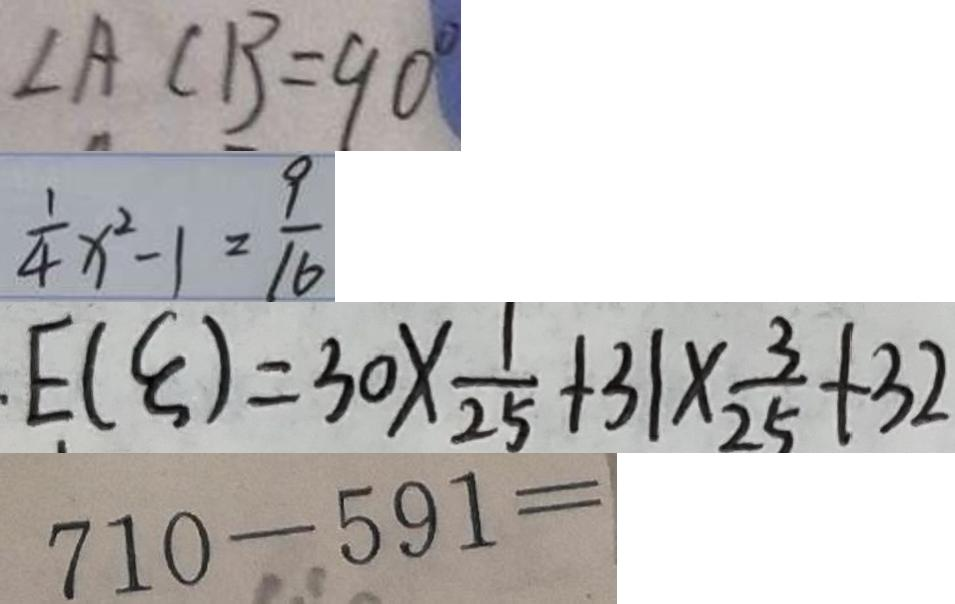<formula> <loc_0><loc_0><loc_500><loc_500>\angle A C B = 9 0 ^ { \circ } 
 \frac { 1 } { 4 } x ^ { 2 } - 1 = \frac { 9 } { 1 6 } 
 E ( \varepsilon ) = 3 0 \times \frac { 1 } { 2 5 } + 3 1 \times \frac { 3 } { 2 5 } + 3 2 
 7 1 0 - 5 9 1 =</formula> 